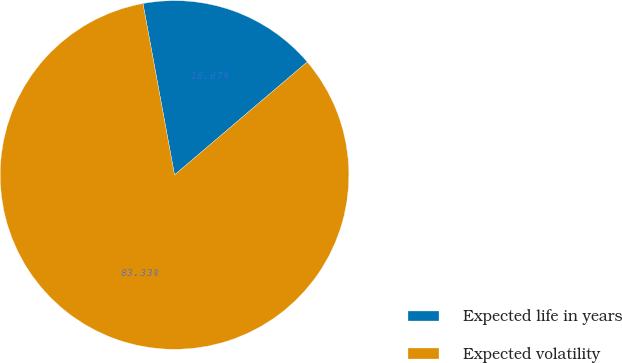<chart> <loc_0><loc_0><loc_500><loc_500><pie_chart><fcel>Expected life in years<fcel>Expected volatility<nl><fcel>16.67%<fcel>83.33%<nl></chart> 